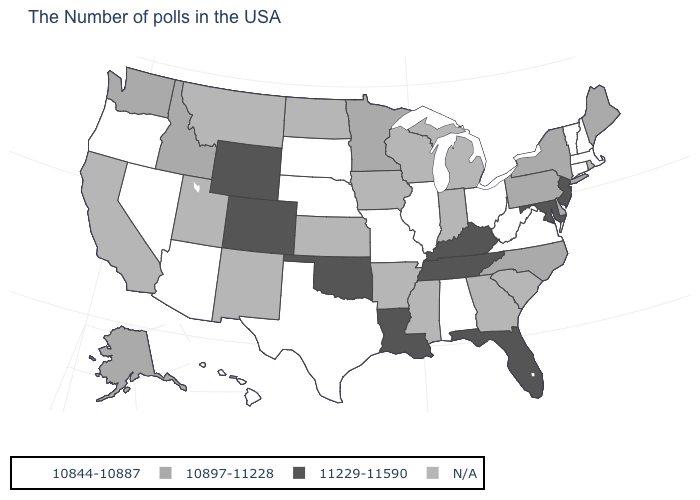Name the states that have a value in the range 10844-10887?
Be succinct. Massachusetts, New Hampshire, Vermont, Connecticut, Virginia, West Virginia, Ohio, Alabama, Illinois, Missouri, Nebraska, Texas, South Dakota, Arizona, Nevada, Oregon, Hawaii. What is the value of Nevada?
Give a very brief answer. 10844-10887. Is the legend a continuous bar?
Write a very short answer. No. What is the value of Idaho?
Give a very brief answer. 10897-11228. Name the states that have a value in the range 10897-11228?
Concise answer only. Maine, New York, Delaware, Pennsylvania, North Carolina, Minnesota, Idaho, Washington, Alaska. Name the states that have a value in the range N/A?
Concise answer only. Rhode Island, South Carolina, Georgia, Michigan, Indiana, Wisconsin, Mississippi, Arkansas, Iowa, Kansas, North Dakota, New Mexico, Utah, Montana, California. Name the states that have a value in the range 11229-11590?
Be succinct. New Jersey, Maryland, Florida, Kentucky, Tennessee, Louisiana, Oklahoma, Wyoming, Colorado. Does Maryland have the highest value in the USA?
Short answer required. Yes. What is the value of North Carolina?
Be succinct. 10897-11228. Does Colorado have the highest value in the USA?
Concise answer only. Yes. Does Oklahoma have the highest value in the USA?
Short answer required. Yes. What is the lowest value in states that border Pennsylvania?
Write a very short answer. 10844-10887. Which states have the lowest value in the USA?
Write a very short answer. Massachusetts, New Hampshire, Vermont, Connecticut, Virginia, West Virginia, Ohio, Alabama, Illinois, Missouri, Nebraska, Texas, South Dakota, Arizona, Nevada, Oregon, Hawaii. Name the states that have a value in the range 10897-11228?
Write a very short answer. Maine, New York, Delaware, Pennsylvania, North Carolina, Minnesota, Idaho, Washington, Alaska. 